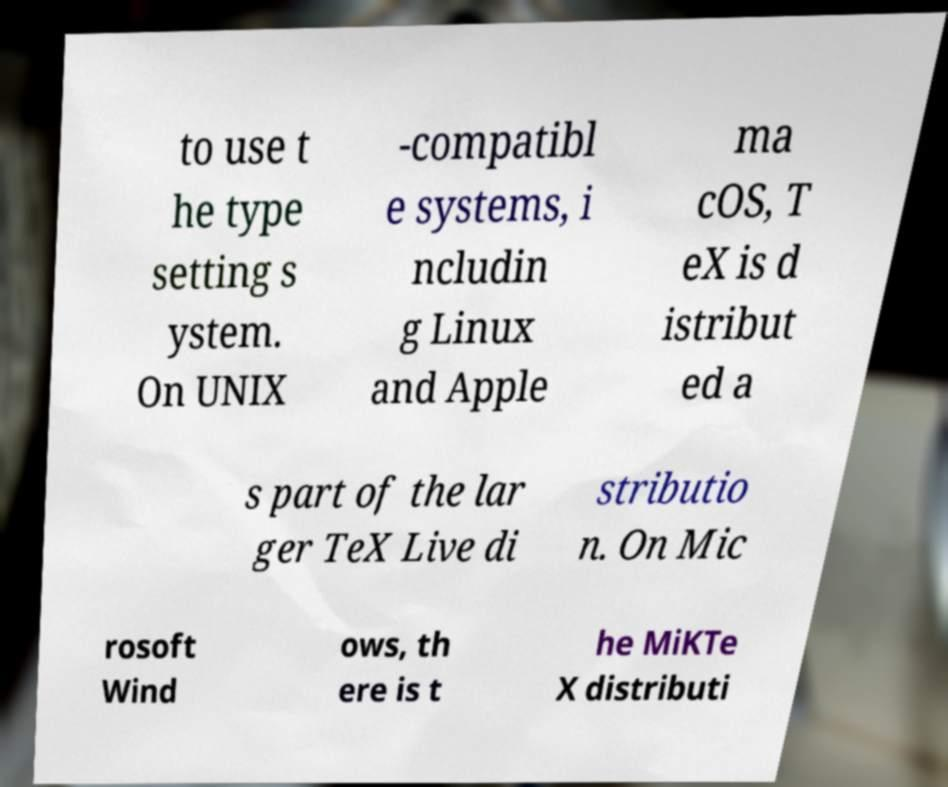Can you read and provide the text displayed in the image?This photo seems to have some interesting text. Can you extract and type it out for me? to use t he type setting s ystem. On UNIX -compatibl e systems, i ncludin g Linux and Apple ma cOS, T eX is d istribut ed a s part of the lar ger TeX Live di stributio n. On Mic rosoft Wind ows, th ere is t he MiKTe X distributi 